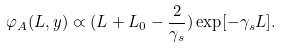<formula> <loc_0><loc_0><loc_500><loc_500>\varphi _ { A } ( L , y ) \varpropto ( L + L _ { 0 } - \frac { 2 } { \gamma _ { s } } ) \exp [ - \gamma _ { s } L ] .</formula> 